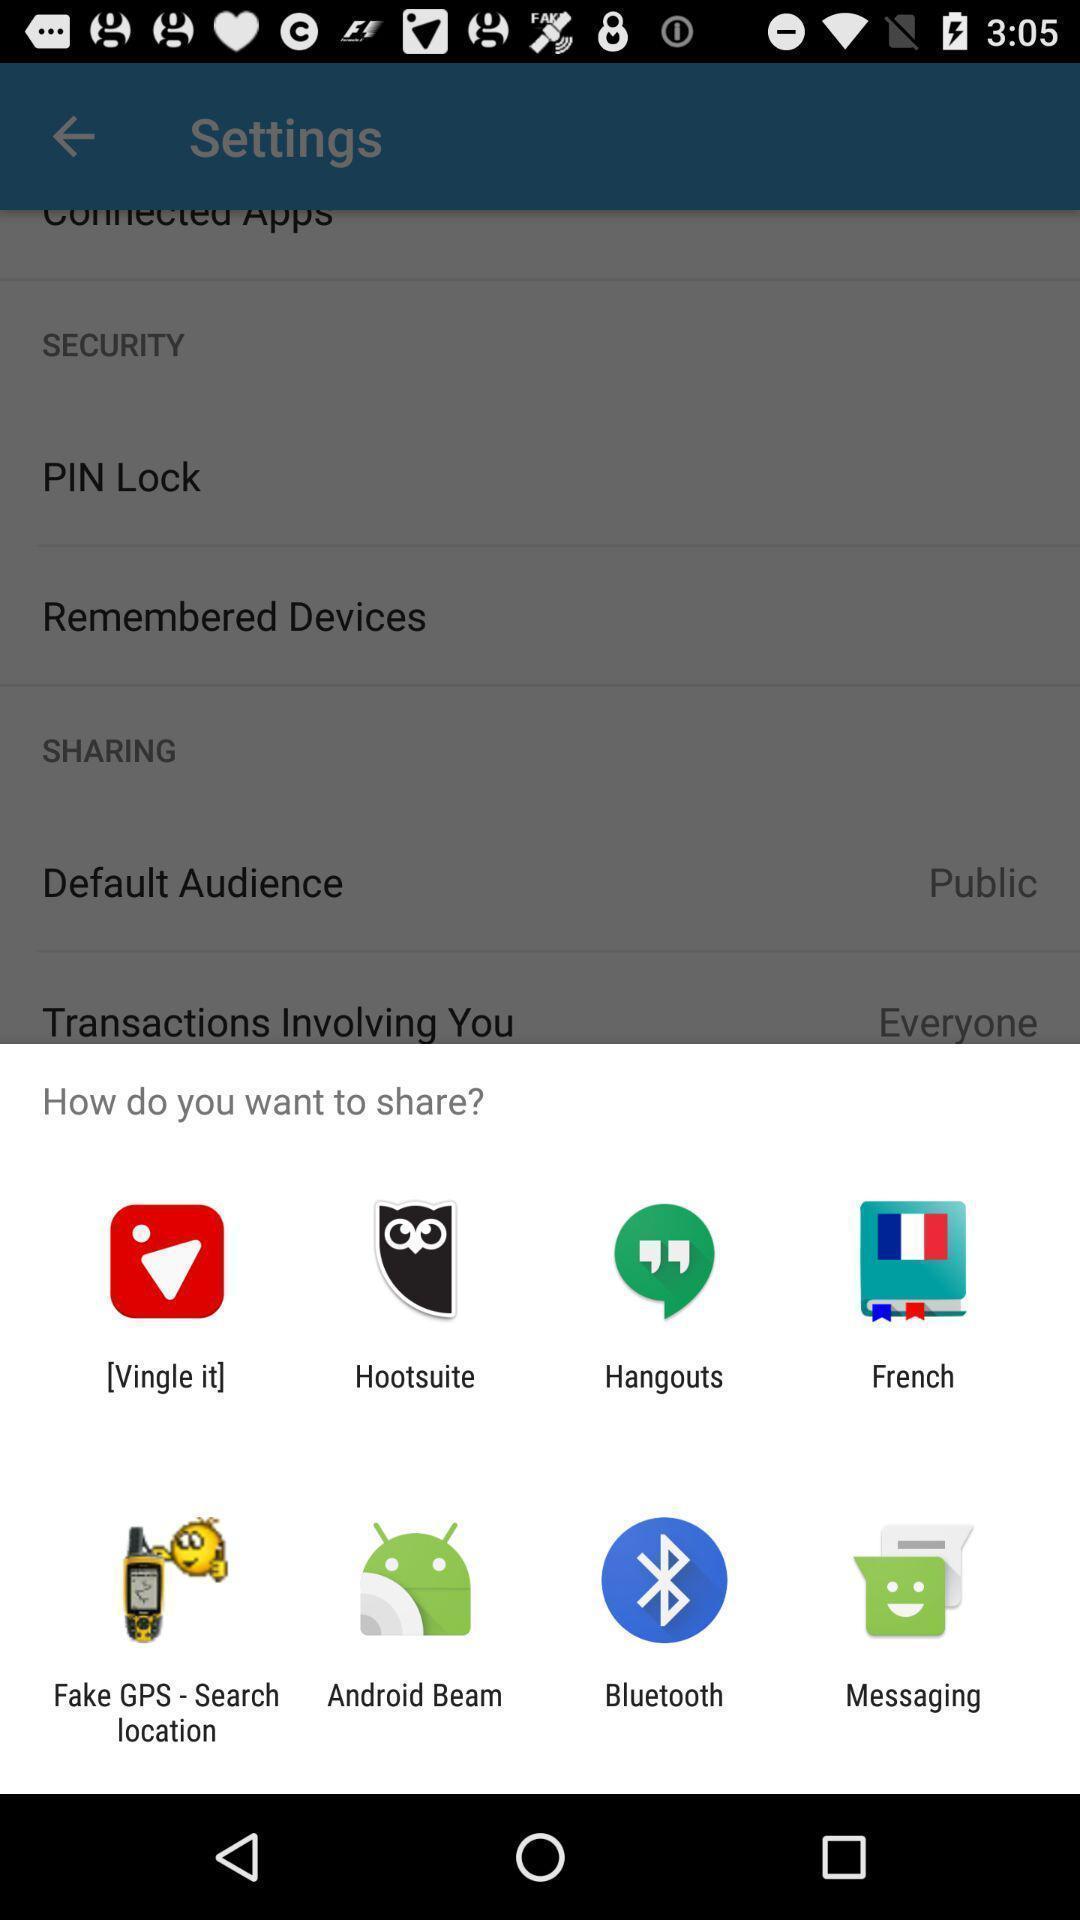Explain what's happening in this screen capture. Pop-up showing different share options. 